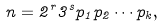Convert formula to latex. <formula><loc_0><loc_0><loc_500><loc_500>n = 2 ^ { r } 3 ^ { s } p _ { 1 } p _ { 2 } \cdots p _ { k } ,</formula> 